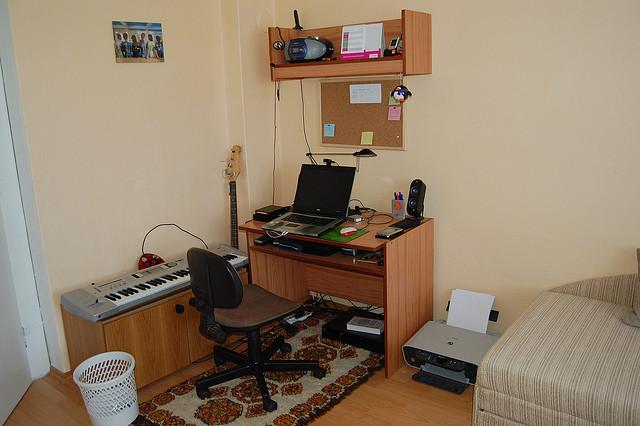Is this a bedroom?
Write a very short answer. Yes. For which member of the family might a room like this be acceptable?
Write a very short answer. Teenager. Is the computer monitor on?
Write a very short answer. No. What color is the desk in the room?
Keep it brief. Brown. What musical instrument is on the table next to the computer?
Be succinct. Keyboard. What is in the corner under the desk?
Write a very short answer. Extension cord. What is the modem sitting on?
Quick response, please. Desk. What type of room does the picture depict?
Be succinct. Bedroom. Why is there a window in this office?
Concise answer only. There isn't. 